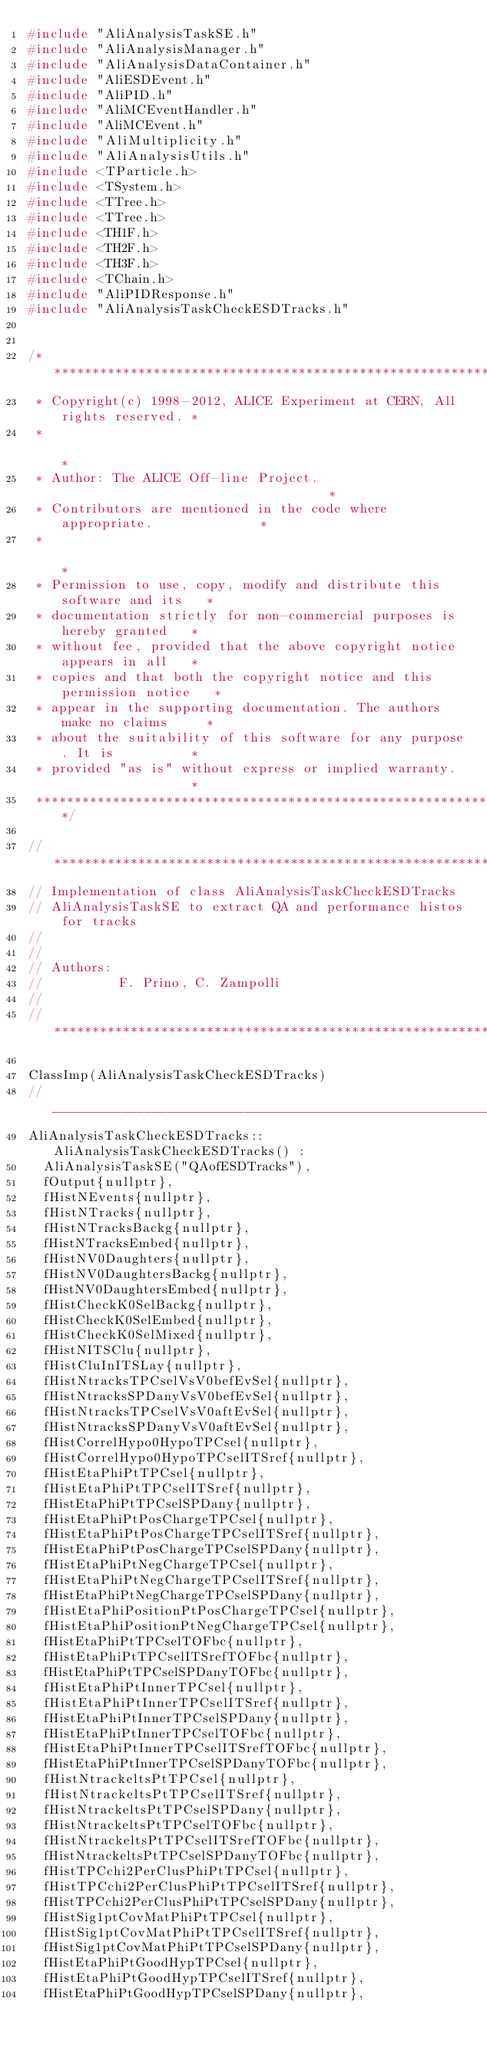<code> <loc_0><loc_0><loc_500><loc_500><_C++_>#include "AliAnalysisTaskSE.h"
#include "AliAnalysisManager.h"
#include "AliAnalysisDataContainer.h"
#include "AliESDEvent.h"
#include "AliPID.h"
#include "AliMCEventHandler.h"
#include "AliMCEvent.h"
#include "AliMultiplicity.h"
#include "AliAnalysisUtils.h"
#include <TParticle.h>
#include <TSystem.h>
#include <TTree.h>
#include <TTree.h>
#include <TH1F.h>
#include <TH2F.h>
#include <TH3F.h>
#include <TChain.h>
#include "AliPIDResponse.h"
#include "AliAnalysisTaskCheckESDTracks.h"


/**************************************************************************
 * Copyright(c) 1998-2012, ALICE Experiment at CERN, All rights reserved. *
 *                                                                        *
 * Author: The ALICE Off-line Project.                                    *
 * Contributors are mentioned in the code where appropriate.              *
 *                                                                        *
 * Permission to use, copy, modify and distribute this software and its   *
 * documentation strictly for non-commercial purposes is hereby granted   *
 * without fee, provided that the above copyright notice appears in all   *
 * copies and that both the copyright notice and this permission notice   *
 * appear in the supporting documentation. The authors make no claims     *
 * about the suitability of this software for any purpose. It is          *
 * provided "as is" without express or implied warranty.                  *
 **************************************************************************/

//*************************************************************************
// Implementation of class AliAnalysisTaskCheckESDTracks
// AliAnalysisTaskSE to extract QA and performance histos for tracks
// 
//
// Authors: 
//          F. Prino, C. Zampolli
//          
//*************************************************************************

ClassImp(AliAnalysisTaskCheckESDTracks)
//______________________________________________________________________________
AliAnalysisTaskCheckESDTracks::AliAnalysisTaskCheckESDTracks() : 
  AliAnalysisTaskSE("QAofESDTracks"), 
  fOutput{nullptr},
  fHistNEvents{nullptr},
  fHistNTracks{nullptr},
  fHistNTracksBackg{nullptr},
  fHistNTracksEmbed{nullptr},
  fHistNV0Daughters{nullptr},
  fHistNV0DaughtersBackg{nullptr},
  fHistNV0DaughtersEmbed{nullptr},
  fHistCheckK0SelBackg{nullptr},
  fHistCheckK0SelEmbed{nullptr},
  fHistCheckK0SelMixed{nullptr},
  fHistNITSClu{nullptr},
  fHistCluInITSLay{nullptr},
  fHistNtracksTPCselVsV0befEvSel{nullptr},
  fHistNtracksSPDanyVsV0befEvSel{nullptr},
  fHistNtracksTPCselVsV0aftEvSel{nullptr},
  fHistNtracksSPDanyVsV0aftEvSel{nullptr},
  fHistCorrelHypo0HypoTPCsel{nullptr},
  fHistCorrelHypo0HypoTPCselITSref{nullptr},
  fHistEtaPhiPtTPCsel{nullptr},
  fHistEtaPhiPtTPCselITSref{nullptr},
  fHistEtaPhiPtTPCselSPDany{nullptr},
  fHistEtaPhiPtPosChargeTPCsel{nullptr},
  fHistEtaPhiPtPosChargeTPCselITSref{nullptr},
  fHistEtaPhiPtPosChargeTPCselSPDany{nullptr},
  fHistEtaPhiPtNegChargeTPCsel{nullptr},
  fHistEtaPhiPtNegChargeTPCselITSref{nullptr},
  fHistEtaPhiPtNegChargeTPCselSPDany{nullptr},
  fHistEtaPhiPositionPtPosChargeTPCsel{nullptr},
  fHistEtaPhiPositionPtNegChargeTPCsel{nullptr},
  fHistEtaPhiPtTPCselTOFbc{nullptr},
  fHistEtaPhiPtTPCselITSrefTOFbc{nullptr},
  fHistEtaPhiPtTPCselSPDanyTOFbc{nullptr},
  fHistEtaPhiPtInnerTPCsel{nullptr},
  fHistEtaPhiPtInnerTPCselITSref{nullptr},
  fHistEtaPhiPtInnerTPCselSPDany{nullptr},
  fHistEtaPhiPtInnerTPCselTOFbc{nullptr},
  fHistEtaPhiPtInnerTPCselITSrefTOFbc{nullptr},
  fHistEtaPhiPtInnerTPCselSPDanyTOFbc{nullptr},
  fHistNtrackeltsPtTPCsel{nullptr},
  fHistNtrackeltsPtTPCselITSref{nullptr},
  fHistNtrackeltsPtTPCselSPDany{nullptr},
  fHistNtrackeltsPtTPCselTOFbc{nullptr},
  fHistNtrackeltsPtTPCselITSrefTOFbc{nullptr},
  fHistNtrackeltsPtTPCselSPDanyTOFbc{nullptr},
  fHistTPCchi2PerClusPhiPtTPCsel{nullptr},
  fHistTPCchi2PerClusPhiPtTPCselITSref{nullptr},
  fHistTPCchi2PerClusPhiPtTPCselSPDany{nullptr},
  fHistSig1ptCovMatPhiPtTPCsel{nullptr},
  fHistSig1ptCovMatPhiPtTPCselITSref{nullptr},
  fHistSig1ptCovMatPhiPtTPCselSPDany{nullptr},
  fHistEtaPhiPtGoodHypTPCsel{nullptr},
  fHistEtaPhiPtGoodHypTPCselITSref{nullptr},
  fHistEtaPhiPtGoodHypTPCselSPDany{nullptr},</code> 